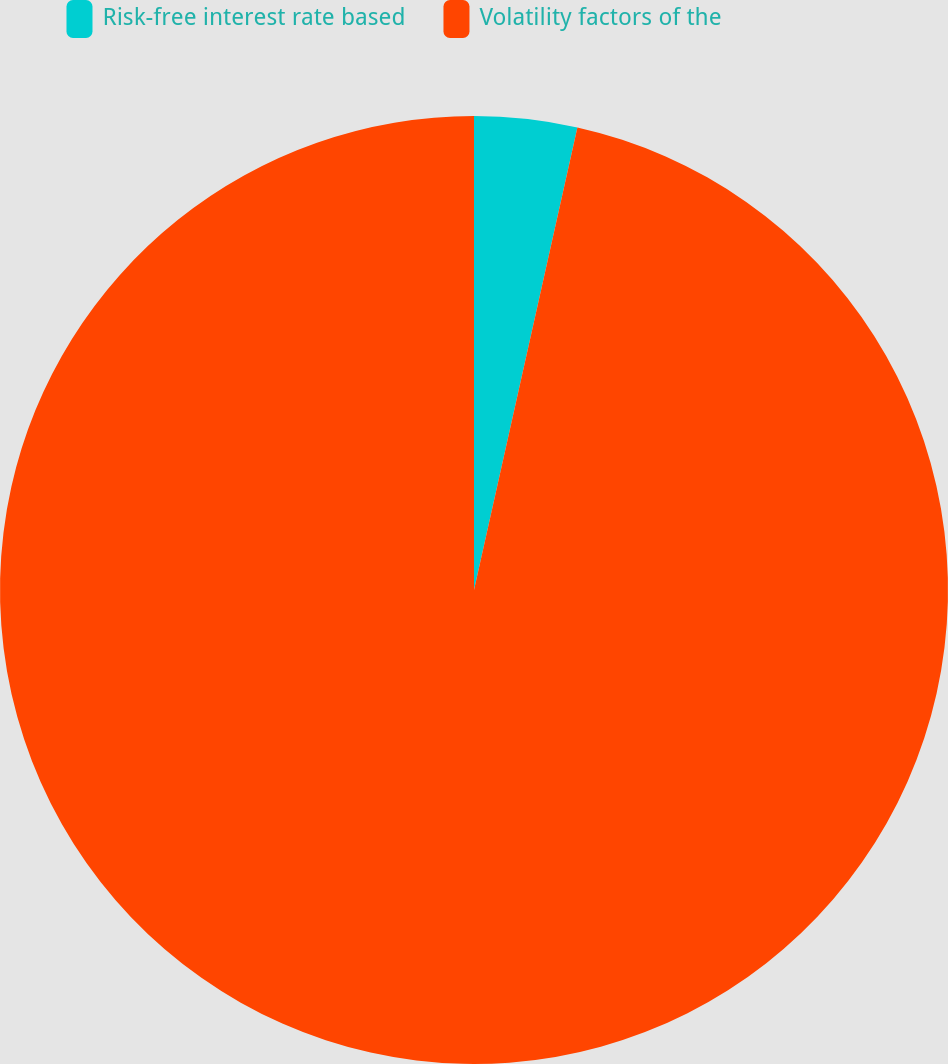Convert chart. <chart><loc_0><loc_0><loc_500><loc_500><pie_chart><fcel>Risk-free interest rate based<fcel>Volatility factors of the<nl><fcel>3.5%<fcel>96.5%<nl></chart> 